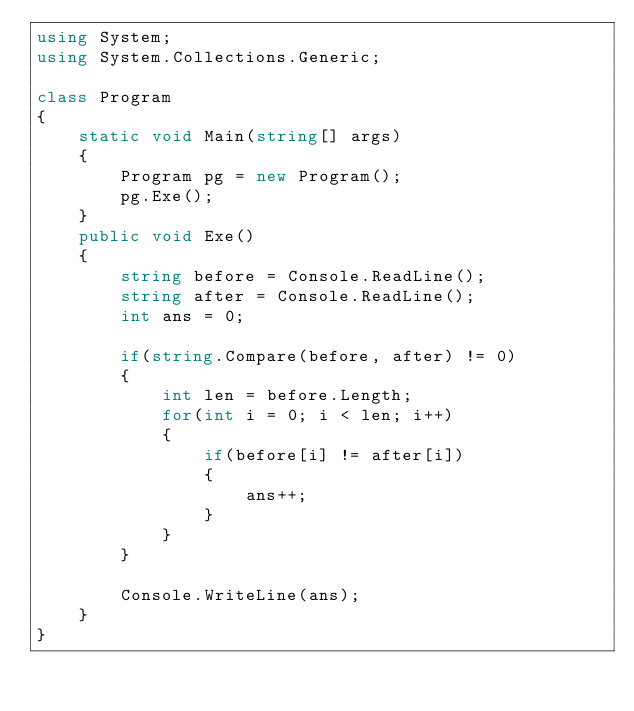Convert code to text. <code><loc_0><loc_0><loc_500><loc_500><_C#_>using System;
using System.Collections.Generic;

class Program
{
    static void Main(string[] args)
    {
        Program pg = new Program();
        pg.Exe();
    }
    public void Exe()
    {
        string before = Console.ReadLine();
        string after = Console.ReadLine();
        int ans = 0;

        if(string.Compare(before, after) != 0)
        {
            int len = before.Length;
            for(int i = 0; i < len; i++)
            {
                if(before[i] != after[i])
                {
                    ans++;
                }
            }
        }

        Console.WriteLine(ans);
    }
}

</code> 